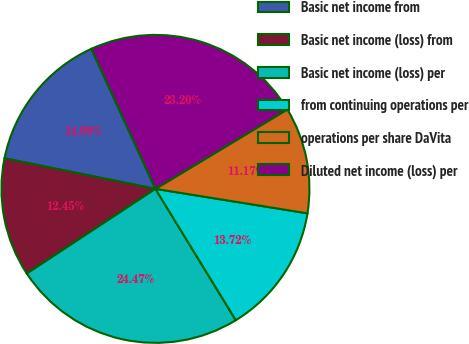<chart> <loc_0><loc_0><loc_500><loc_500><pie_chart><fcel>Basic net income from<fcel>Basic net income (loss) from<fcel>Basic net income (loss) per<fcel>from continuing operations per<fcel>operations per share DaVita<fcel>Diluted net income (loss) per<nl><fcel>14.99%<fcel>12.45%<fcel>24.47%<fcel>13.72%<fcel>11.17%<fcel>23.2%<nl></chart> 